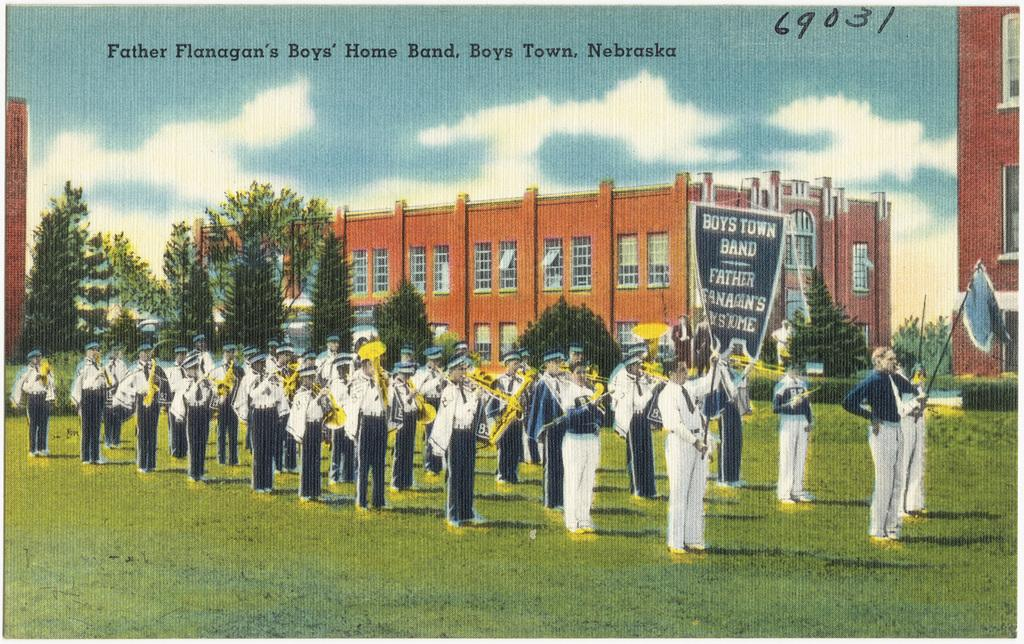<image>
Present a compact description of the photo's key features. Postcard showing a marching band and the numbers "69031" on the top. 